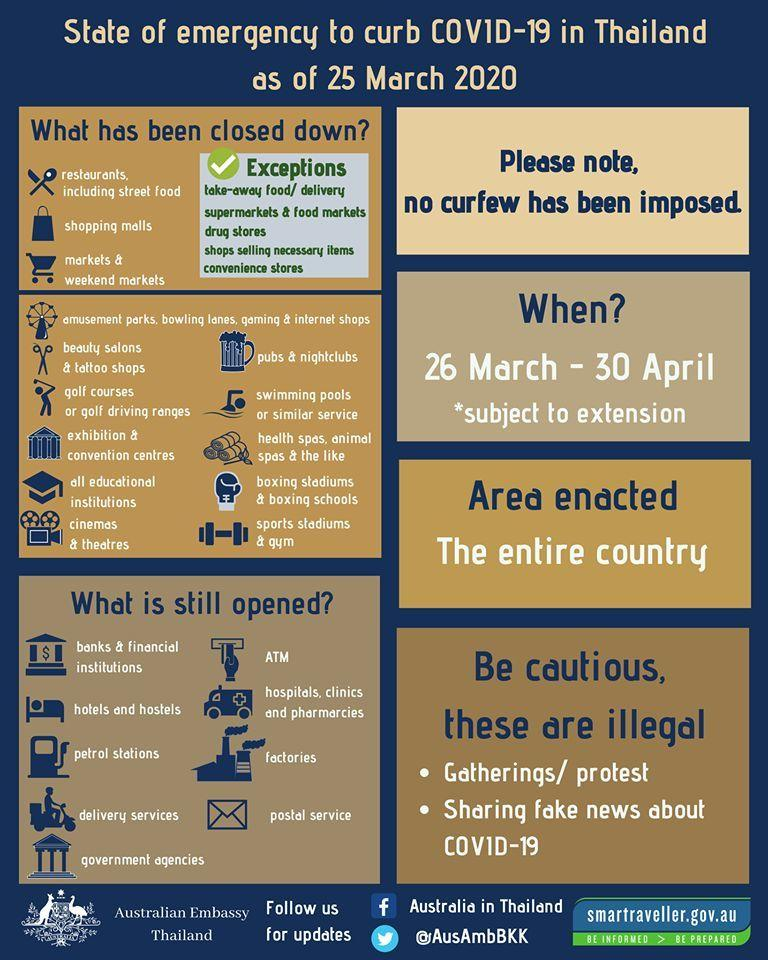Identify some key points in this picture. The Facebook profile belongs to an individual who resides in Australia and is currently in Thailand. The Twitter handle provided is "@AusAmbBKK". 